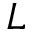<formula> <loc_0><loc_0><loc_500><loc_500>L</formula> 